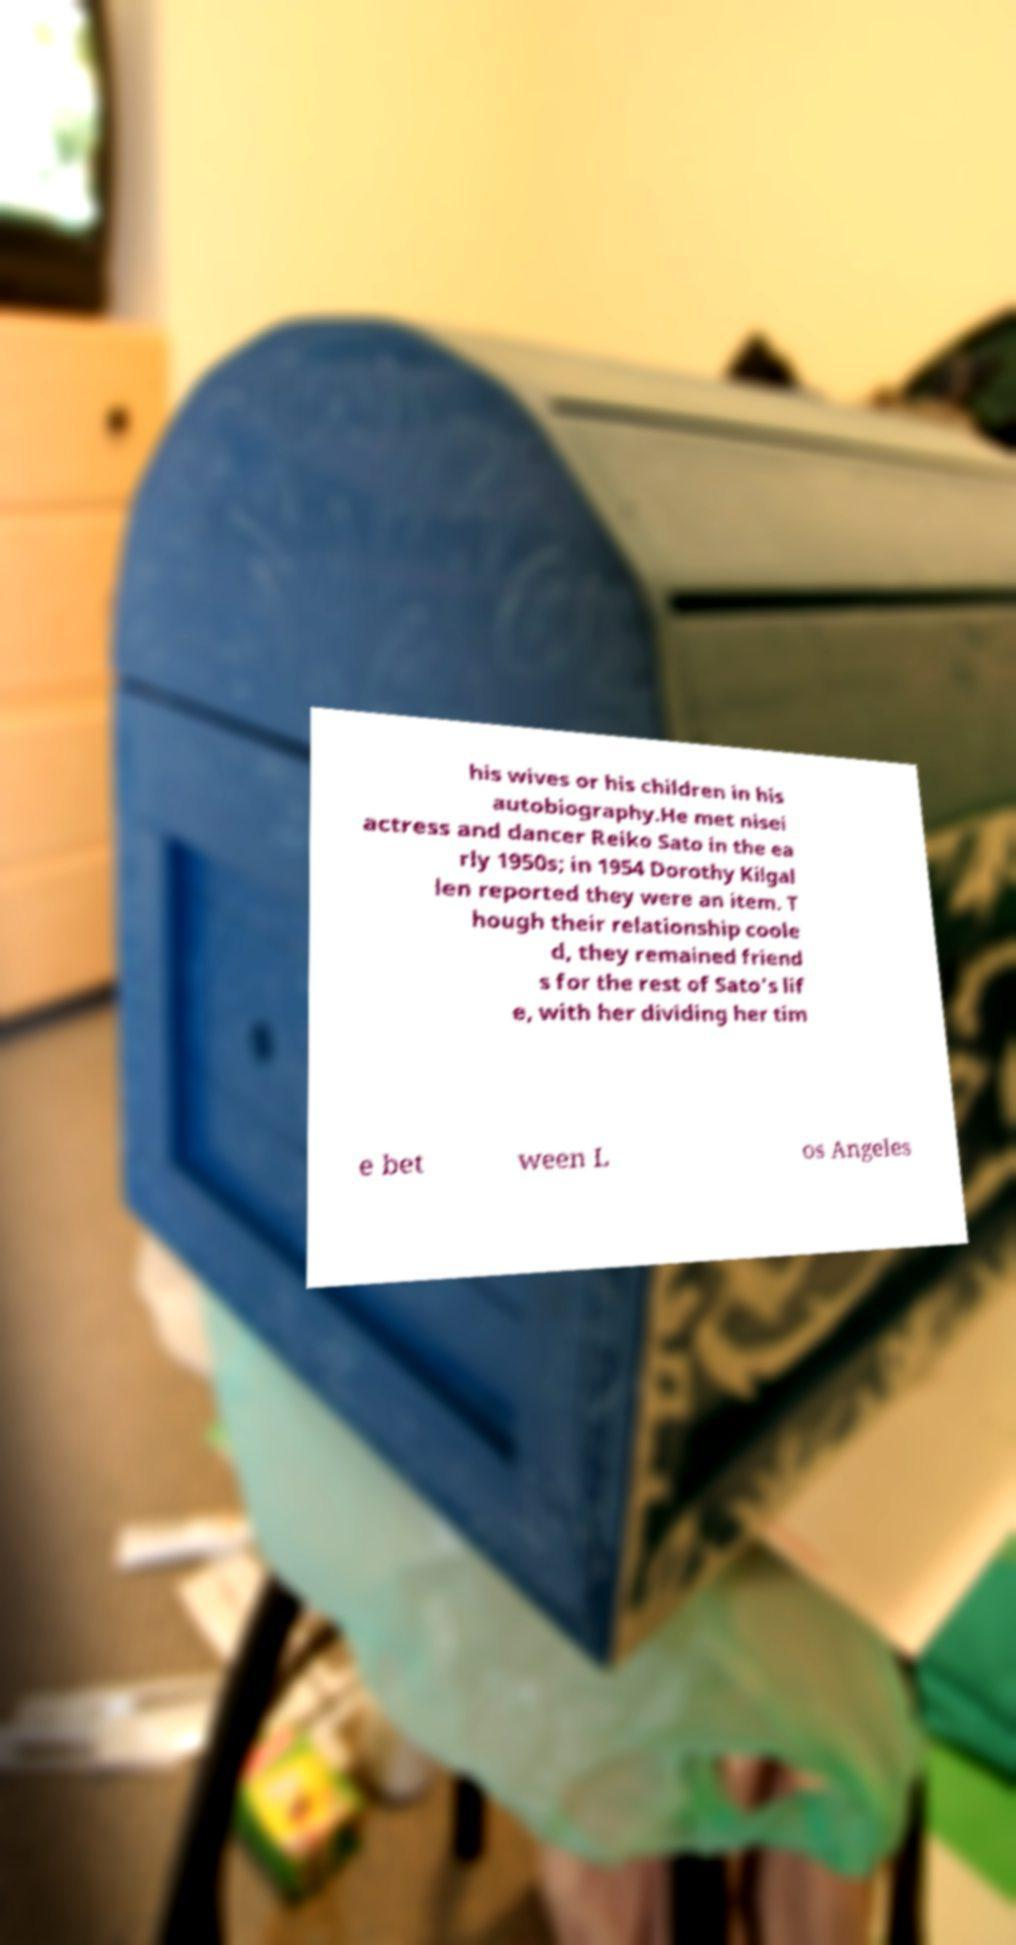Please read and relay the text visible in this image. What does it say? his wives or his children in his autobiography.He met nisei actress and dancer Reiko Sato in the ea rly 1950s; in 1954 Dorothy Kilgal len reported they were an item. T hough their relationship coole d, they remained friend s for the rest of Sato's lif e, with her dividing her tim e bet ween L os Angeles 